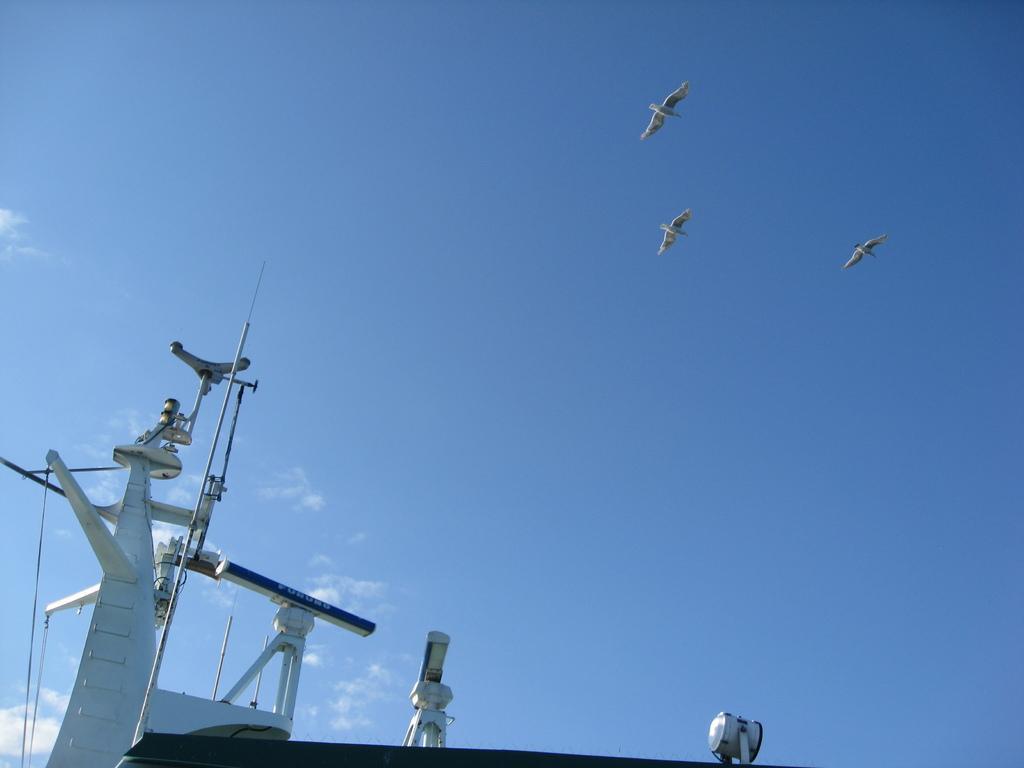In one or two sentences, can you explain what this image depicts? This image is taken outdoors. At the top of the image there is a sky with clouds and three birds are flying in the sky. At the bottom of the image there is a ship. 